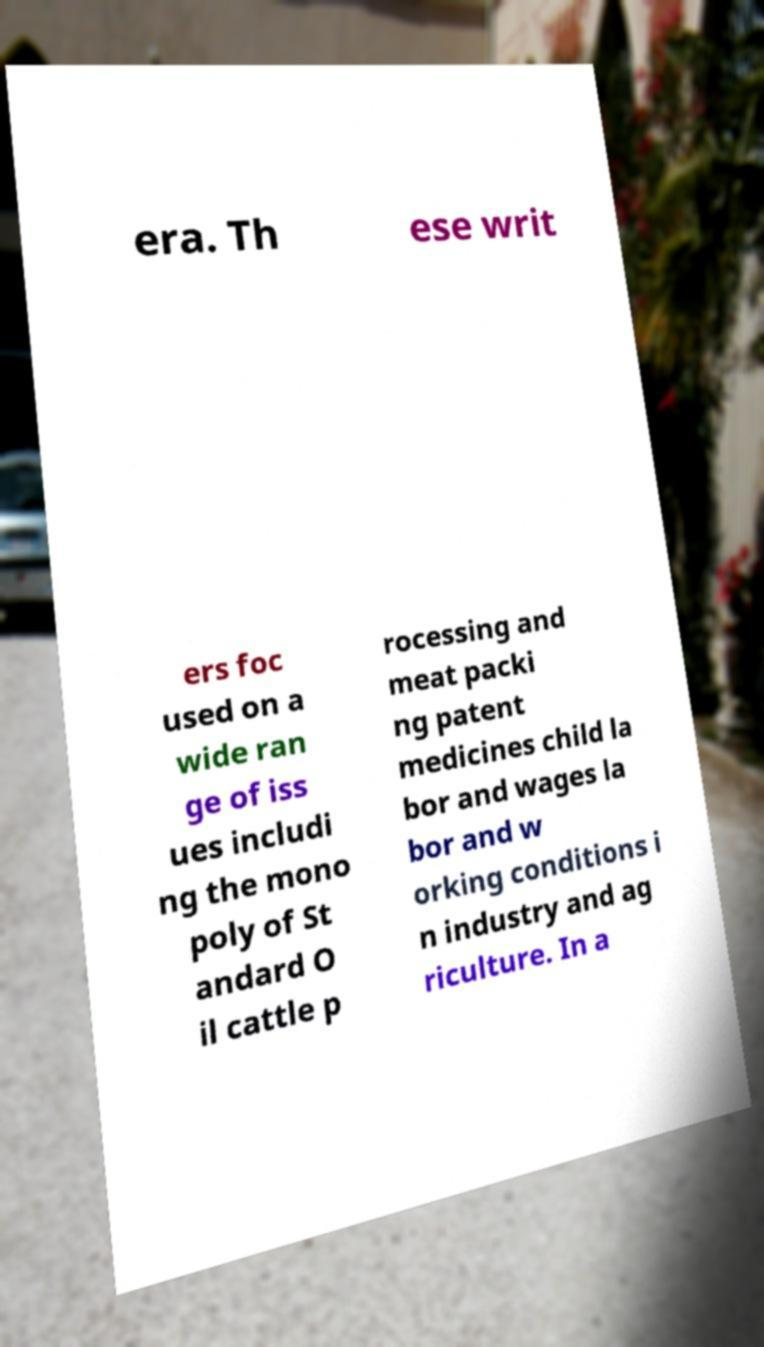Please identify and transcribe the text found in this image. era. Th ese writ ers foc used on a wide ran ge of iss ues includi ng the mono poly of St andard O il cattle p rocessing and meat packi ng patent medicines child la bor and wages la bor and w orking conditions i n industry and ag riculture. In a 